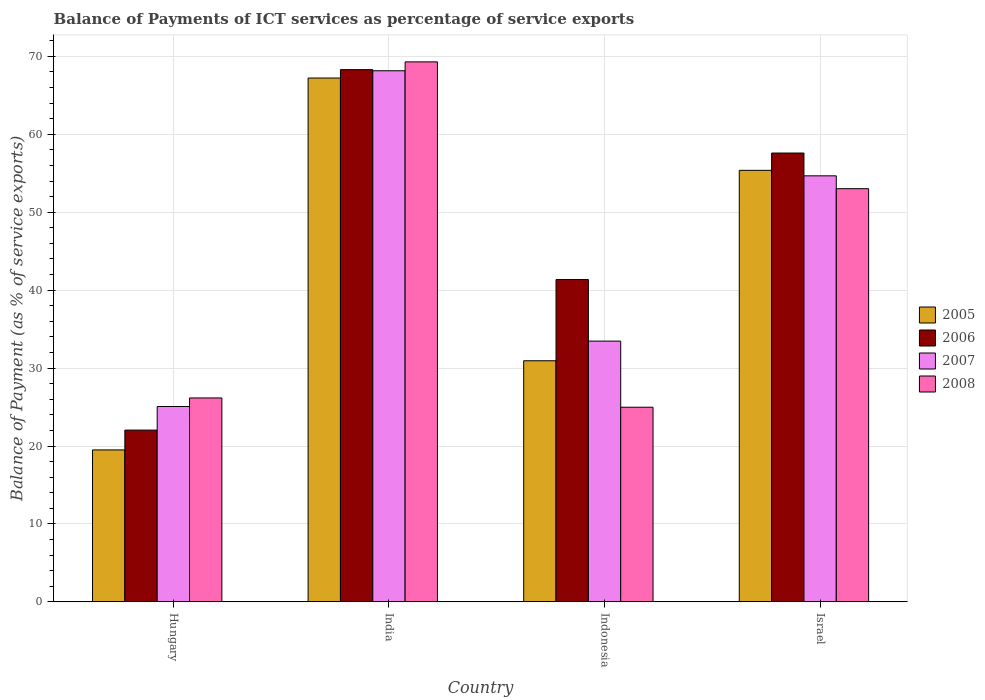How many groups of bars are there?
Ensure brevity in your answer.  4. What is the label of the 2nd group of bars from the left?
Ensure brevity in your answer.  India. In how many cases, is the number of bars for a given country not equal to the number of legend labels?
Give a very brief answer. 0. What is the balance of payments of ICT services in 2008 in Indonesia?
Your answer should be compact. 24.98. Across all countries, what is the maximum balance of payments of ICT services in 2007?
Give a very brief answer. 68.15. Across all countries, what is the minimum balance of payments of ICT services in 2006?
Your answer should be very brief. 22.04. In which country was the balance of payments of ICT services in 2008 maximum?
Your answer should be very brief. India. In which country was the balance of payments of ICT services in 2005 minimum?
Your response must be concise. Hungary. What is the total balance of payments of ICT services in 2008 in the graph?
Offer a terse response. 173.45. What is the difference between the balance of payments of ICT services in 2008 in India and that in Indonesia?
Ensure brevity in your answer.  44.31. What is the difference between the balance of payments of ICT services in 2007 in Israel and the balance of payments of ICT services in 2008 in Hungary?
Offer a terse response. 28.5. What is the average balance of payments of ICT services in 2008 per country?
Make the answer very short. 43.36. What is the difference between the balance of payments of ICT services of/in 2008 and balance of payments of ICT services of/in 2007 in Hungary?
Ensure brevity in your answer.  1.1. In how many countries, is the balance of payments of ICT services in 2008 greater than 62 %?
Give a very brief answer. 1. What is the ratio of the balance of payments of ICT services in 2005 in Hungary to that in Indonesia?
Your response must be concise. 0.63. Is the balance of payments of ICT services in 2005 in India less than that in Israel?
Offer a very short reply. No. What is the difference between the highest and the second highest balance of payments of ICT services in 2005?
Give a very brief answer. 36.28. What is the difference between the highest and the lowest balance of payments of ICT services in 2006?
Offer a terse response. 46.25. Is the sum of the balance of payments of ICT services in 2006 in Indonesia and Israel greater than the maximum balance of payments of ICT services in 2005 across all countries?
Ensure brevity in your answer.  Yes. What does the 2nd bar from the left in India represents?
Keep it short and to the point. 2006. What does the 3rd bar from the right in Israel represents?
Make the answer very short. 2006. How many bars are there?
Offer a very short reply. 16. How many countries are there in the graph?
Keep it short and to the point. 4. Does the graph contain any zero values?
Offer a terse response. No. Does the graph contain grids?
Offer a very short reply. Yes. What is the title of the graph?
Make the answer very short. Balance of Payments of ICT services as percentage of service exports. What is the label or title of the X-axis?
Ensure brevity in your answer.  Country. What is the label or title of the Y-axis?
Ensure brevity in your answer.  Balance of Payment (as % of service exports). What is the Balance of Payment (as % of service exports) in 2005 in Hungary?
Offer a very short reply. 19.5. What is the Balance of Payment (as % of service exports) of 2006 in Hungary?
Your response must be concise. 22.04. What is the Balance of Payment (as % of service exports) of 2007 in Hungary?
Your answer should be compact. 25.07. What is the Balance of Payment (as % of service exports) in 2008 in Hungary?
Ensure brevity in your answer.  26.17. What is the Balance of Payment (as % of service exports) of 2005 in India?
Your answer should be very brief. 67.22. What is the Balance of Payment (as % of service exports) in 2006 in India?
Your answer should be very brief. 68.29. What is the Balance of Payment (as % of service exports) of 2007 in India?
Your answer should be very brief. 68.15. What is the Balance of Payment (as % of service exports) in 2008 in India?
Provide a succinct answer. 69.29. What is the Balance of Payment (as % of service exports) in 2005 in Indonesia?
Provide a succinct answer. 30.94. What is the Balance of Payment (as % of service exports) in 2006 in Indonesia?
Make the answer very short. 41.36. What is the Balance of Payment (as % of service exports) in 2007 in Indonesia?
Provide a short and direct response. 33.46. What is the Balance of Payment (as % of service exports) of 2008 in Indonesia?
Give a very brief answer. 24.98. What is the Balance of Payment (as % of service exports) of 2005 in Israel?
Keep it short and to the point. 55.37. What is the Balance of Payment (as % of service exports) of 2006 in Israel?
Provide a short and direct response. 57.59. What is the Balance of Payment (as % of service exports) in 2007 in Israel?
Keep it short and to the point. 54.67. What is the Balance of Payment (as % of service exports) in 2008 in Israel?
Your answer should be compact. 53.02. Across all countries, what is the maximum Balance of Payment (as % of service exports) of 2005?
Provide a succinct answer. 67.22. Across all countries, what is the maximum Balance of Payment (as % of service exports) in 2006?
Your response must be concise. 68.29. Across all countries, what is the maximum Balance of Payment (as % of service exports) of 2007?
Offer a terse response. 68.15. Across all countries, what is the maximum Balance of Payment (as % of service exports) of 2008?
Provide a short and direct response. 69.29. Across all countries, what is the minimum Balance of Payment (as % of service exports) of 2005?
Offer a terse response. 19.5. Across all countries, what is the minimum Balance of Payment (as % of service exports) of 2006?
Your response must be concise. 22.04. Across all countries, what is the minimum Balance of Payment (as % of service exports) of 2007?
Offer a very short reply. 25.07. Across all countries, what is the minimum Balance of Payment (as % of service exports) of 2008?
Keep it short and to the point. 24.98. What is the total Balance of Payment (as % of service exports) in 2005 in the graph?
Provide a short and direct response. 173.03. What is the total Balance of Payment (as % of service exports) of 2006 in the graph?
Your answer should be very brief. 189.29. What is the total Balance of Payment (as % of service exports) in 2007 in the graph?
Provide a short and direct response. 181.34. What is the total Balance of Payment (as % of service exports) of 2008 in the graph?
Provide a short and direct response. 173.45. What is the difference between the Balance of Payment (as % of service exports) of 2005 in Hungary and that in India?
Your answer should be very brief. -47.72. What is the difference between the Balance of Payment (as % of service exports) in 2006 in Hungary and that in India?
Give a very brief answer. -46.25. What is the difference between the Balance of Payment (as % of service exports) of 2007 in Hungary and that in India?
Your answer should be compact. -43.08. What is the difference between the Balance of Payment (as % of service exports) in 2008 in Hungary and that in India?
Give a very brief answer. -43.12. What is the difference between the Balance of Payment (as % of service exports) of 2005 in Hungary and that in Indonesia?
Ensure brevity in your answer.  -11.44. What is the difference between the Balance of Payment (as % of service exports) in 2006 in Hungary and that in Indonesia?
Make the answer very short. -19.32. What is the difference between the Balance of Payment (as % of service exports) in 2007 in Hungary and that in Indonesia?
Provide a short and direct response. -8.39. What is the difference between the Balance of Payment (as % of service exports) of 2008 in Hungary and that in Indonesia?
Keep it short and to the point. 1.19. What is the difference between the Balance of Payment (as % of service exports) of 2005 in Hungary and that in Israel?
Keep it short and to the point. -35.88. What is the difference between the Balance of Payment (as % of service exports) in 2006 in Hungary and that in Israel?
Ensure brevity in your answer.  -35.55. What is the difference between the Balance of Payment (as % of service exports) of 2007 in Hungary and that in Israel?
Your answer should be compact. -29.6. What is the difference between the Balance of Payment (as % of service exports) in 2008 in Hungary and that in Israel?
Offer a terse response. -26.85. What is the difference between the Balance of Payment (as % of service exports) of 2005 in India and that in Indonesia?
Your answer should be compact. 36.28. What is the difference between the Balance of Payment (as % of service exports) in 2006 in India and that in Indonesia?
Your response must be concise. 26.93. What is the difference between the Balance of Payment (as % of service exports) of 2007 in India and that in Indonesia?
Your answer should be very brief. 34.69. What is the difference between the Balance of Payment (as % of service exports) of 2008 in India and that in Indonesia?
Offer a terse response. 44.31. What is the difference between the Balance of Payment (as % of service exports) in 2005 in India and that in Israel?
Give a very brief answer. 11.85. What is the difference between the Balance of Payment (as % of service exports) of 2006 in India and that in Israel?
Give a very brief answer. 10.7. What is the difference between the Balance of Payment (as % of service exports) of 2007 in India and that in Israel?
Provide a short and direct response. 13.48. What is the difference between the Balance of Payment (as % of service exports) in 2008 in India and that in Israel?
Offer a very short reply. 16.27. What is the difference between the Balance of Payment (as % of service exports) in 2005 in Indonesia and that in Israel?
Keep it short and to the point. -24.44. What is the difference between the Balance of Payment (as % of service exports) of 2006 in Indonesia and that in Israel?
Offer a terse response. -16.23. What is the difference between the Balance of Payment (as % of service exports) in 2007 in Indonesia and that in Israel?
Offer a very short reply. -21.21. What is the difference between the Balance of Payment (as % of service exports) of 2008 in Indonesia and that in Israel?
Provide a short and direct response. -28.04. What is the difference between the Balance of Payment (as % of service exports) in 2005 in Hungary and the Balance of Payment (as % of service exports) in 2006 in India?
Offer a terse response. -48.8. What is the difference between the Balance of Payment (as % of service exports) of 2005 in Hungary and the Balance of Payment (as % of service exports) of 2007 in India?
Offer a terse response. -48.65. What is the difference between the Balance of Payment (as % of service exports) in 2005 in Hungary and the Balance of Payment (as % of service exports) in 2008 in India?
Provide a short and direct response. -49.79. What is the difference between the Balance of Payment (as % of service exports) of 2006 in Hungary and the Balance of Payment (as % of service exports) of 2007 in India?
Offer a very short reply. -46.11. What is the difference between the Balance of Payment (as % of service exports) of 2006 in Hungary and the Balance of Payment (as % of service exports) of 2008 in India?
Ensure brevity in your answer.  -47.25. What is the difference between the Balance of Payment (as % of service exports) in 2007 in Hungary and the Balance of Payment (as % of service exports) in 2008 in India?
Give a very brief answer. -44.22. What is the difference between the Balance of Payment (as % of service exports) of 2005 in Hungary and the Balance of Payment (as % of service exports) of 2006 in Indonesia?
Your answer should be compact. -21.87. What is the difference between the Balance of Payment (as % of service exports) of 2005 in Hungary and the Balance of Payment (as % of service exports) of 2007 in Indonesia?
Your answer should be compact. -13.96. What is the difference between the Balance of Payment (as % of service exports) of 2005 in Hungary and the Balance of Payment (as % of service exports) of 2008 in Indonesia?
Give a very brief answer. -5.48. What is the difference between the Balance of Payment (as % of service exports) in 2006 in Hungary and the Balance of Payment (as % of service exports) in 2007 in Indonesia?
Provide a short and direct response. -11.42. What is the difference between the Balance of Payment (as % of service exports) of 2006 in Hungary and the Balance of Payment (as % of service exports) of 2008 in Indonesia?
Offer a very short reply. -2.94. What is the difference between the Balance of Payment (as % of service exports) of 2007 in Hungary and the Balance of Payment (as % of service exports) of 2008 in Indonesia?
Provide a succinct answer. 0.09. What is the difference between the Balance of Payment (as % of service exports) in 2005 in Hungary and the Balance of Payment (as % of service exports) in 2006 in Israel?
Provide a short and direct response. -38.1. What is the difference between the Balance of Payment (as % of service exports) in 2005 in Hungary and the Balance of Payment (as % of service exports) in 2007 in Israel?
Keep it short and to the point. -35.17. What is the difference between the Balance of Payment (as % of service exports) in 2005 in Hungary and the Balance of Payment (as % of service exports) in 2008 in Israel?
Make the answer very short. -33.52. What is the difference between the Balance of Payment (as % of service exports) of 2006 in Hungary and the Balance of Payment (as % of service exports) of 2007 in Israel?
Provide a short and direct response. -32.63. What is the difference between the Balance of Payment (as % of service exports) of 2006 in Hungary and the Balance of Payment (as % of service exports) of 2008 in Israel?
Offer a very short reply. -30.98. What is the difference between the Balance of Payment (as % of service exports) in 2007 in Hungary and the Balance of Payment (as % of service exports) in 2008 in Israel?
Ensure brevity in your answer.  -27.95. What is the difference between the Balance of Payment (as % of service exports) of 2005 in India and the Balance of Payment (as % of service exports) of 2006 in Indonesia?
Give a very brief answer. 25.86. What is the difference between the Balance of Payment (as % of service exports) of 2005 in India and the Balance of Payment (as % of service exports) of 2007 in Indonesia?
Offer a very short reply. 33.76. What is the difference between the Balance of Payment (as % of service exports) in 2005 in India and the Balance of Payment (as % of service exports) in 2008 in Indonesia?
Your answer should be very brief. 42.24. What is the difference between the Balance of Payment (as % of service exports) of 2006 in India and the Balance of Payment (as % of service exports) of 2007 in Indonesia?
Ensure brevity in your answer.  34.84. What is the difference between the Balance of Payment (as % of service exports) in 2006 in India and the Balance of Payment (as % of service exports) in 2008 in Indonesia?
Provide a succinct answer. 43.32. What is the difference between the Balance of Payment (as % of service exports) in 2007 in India and the Balance of Payment (as % of service exports) in 2008 in Indonesia?
Your answer should be very brief. 43.17. What is the difference between the Balance of Payment (as % of service exports) of 2005 in India and the Balance of Payment (as % of service exports) of 2006 in Israel?
Ensure brevity in your answer.  9.63. What is the difference between the Balance of Payment (as % of service exports) in 2005 in India and the Balance of Payment (as % of service exports) in 2007 in Israel?
Offer a very short reply. 12.55. What is the difference between the Balance of Payment (as % of service exports) in 2005 in India and the Balance of Payment (as % of service exports) in 2008 in Israel?
Offer a terse response. 14.2. What is the difference between the Balance of Payment (as % of service exports) in 2006 in India and the Balance of Payment (as % of service exports) in 2007 in Israel?
Provide a short and direct response. 13.63. What is the difference between the Balance of Payment (as % of service exports) in 2006 in India and the Balance of Payment (as % of service exports) in 2008 in Israel?
Keep it short and to the point. 15.28. What is the difference between the Balance of Payment (as % of service exports) of 2007 in India and the Balance of Payment (as % of service exports) of 2008 in Israel?
Make the answer very short. 15.13. What is the difference between the Balance of Payment (as % of service exports) in 2005 in Indonesia and the Balance of Payment (as % of service exports) in 2006 in Israel?
Ensure brevity in your answer.  -26.65. What is the difference between the Balance of Payment (as % of service exports) in 2005 in Indonesia and the Balance of Payment (as % of service exports) in 2007 in Israel?
Give a very brief answer. -23.73. What is the difference between the Balance of Payment (as % of service exports) in 2005 in Indonesia and the Balance of Payment (as % of service exports) in 2008 in Israel?
Give a very brief answer. -22.08. What is the difference between the Balance of Payment (as % of service exports) in 2006 in Indonesia and the Balance of Payment (as % of service exports) in 2007 in Israel?
Ensure brevity in your answer.  -13.3. What is the difference between the Balance of Payment (as % of service exports) in 2006 in Indonesia and the Balance of Payment (as % of service exports) in 2008 in Israel?
Offer a terse response. -11.66. What is the difference between the Balance of Payment (as % of service exports) of 2007 in Indonesia and the Balance of Payment (as % of service exports) of 2008 in Israel?
Your response must be concise. -19.56. What is the average Balance of Payment (as % of service exports) of 2005 per country?
Your answer should be very brief. 43.26. What is the average Balance of Payment (as % of service exports) in 2006 per country?
Your response must be concise. 47.32. What is the average Balance of Payment (as % of service exports) of 2007 per country?
Your answer should be compact. 45.34. What is the average Balance of Payment (as % of service exports) of 2008 per country?
Give a very brief answer. 43.36. What is the difference between the Balance of Payment (as % of service exports) of 2005 and Balance of Payment (as % of service exports) of 2006 in Hungary?
Ensure brevity in your answer.  -2.55. What is the difference between the Balance of Payment (as % of service exports) in 2005 and Balance of Payment (as % of service exports) in 2007 in Hungary?
Your answer should be compact. -5.57. What is the difference between the Balance of Payment (as % of service exports) in 2005 and Balance of Payment (as % of service exports) in 2008 in Hungary?
Provide a succinct answer. -6.67. What is the difference between the Balance of Payment (as % of service exports) of 2006 and Balance of Payment (as % of service exports) of 2007 in Hungary?
Your answer should be compact. -3.03. What is the difference between the Balance of Payment (as % of service exports) in 2006 and Balance of Payment (as % of service exports) in 2008 in Hungary?
Make the answer very short. -4.13. What is the difference between the Balance of Payment (as % of service exports) in 2007 and Balance of Payment (as % of service exports) in 2008 in Hungary?
Give a very brief answer. -1.1. What is the difference between the Balance of Payment (as % of service exports) in 2005 and Balance of Payment (as % of service exports) in 2006 in India?
Offer a very short reply. -1.08. What is the difference between the Balance of Payment (as % of service exports) of 2005 and Balance of Payment (as % of service exports) of 2007 in India?
Your answer should be compact. -0.93. What is the difference between the Balance of Payment (as % of service exports) in 2005 and Balance of Payment (as % of service exports) in 2008 in India?
Your response must be concise. -2.07. What is the difference between the Balance of Payment (as % of service exports) in 2006 and Balance of Payment (as % of service exports) in 2007 in India?
Keep it short and to the point. 0.15. What is the difference between the Balance of Payment (as % of service exports) of 2006 and Balance of Payment (as % of service exports) of 2008 in India?
Make the answer very short. -0.99. What is the difference between the Balance of Payment (as % of service exports) in 2007 and Balance of Payment (as % of service exports) in 2008 in India?
Your answer should be compact. -1.14. What is the difference between the Balance of Payment (as % of service exports) of 2005 and Balance of Payment (as % of service exports) of 2006 in Indonesia?
Your answer should be very brief. -10.42. What is the difference between the Balance of Payment (as % of service exports) in 2005 and Balance of Payment (as % of service exports) in 2007 in Indonesia?
Your answer should be compact. -2.52. What is the difference between the Balance of Payment (as % of service exports) in 2005 and Balance of Payment (as % of service exports) in 2008 in Indonesia?
Ensure brevity in your answer.  5.96. What is the difference between the Balance of Payment (as % of service exports) of 2006 and Balance of Payment (as % of service exports) of 2007 in Indonesia?
Give a very brief answer. 7.9. What is the difference between the Balance of Payment (as % of service exports) of 2006 and Balance of Payment (as % of service exports) of 2008 in Indonesia?
Your answer should be compact. 16.39. What is the difference between the Balance of Payment (as % of service exports) of 2007 and Balance of Payment (as % of service exports) of 2008 in Indonesia?
Give a very brief answer. 8.48. What is the difference between the Balance of Payment (as % of service exports) of 2005 and Balance of Payment (as % of service exports) of 2006 in Israel?
Ensure brevity in your answer.  -2.22. What is the difference between the Balance of Payment (as % of service exports) in 2005 and Balance of Payment (as % of service exports) in 2007 in Israel?
Your response must be concise. 0.71. What is the difference between the Balance of Payment (as % of service exports) of 2005 and Balance of Payment (as % of service exports) of 2008 in Israel?
Give a very brief answer. 2.36. What is the difference between the Balance of Payment (as % of service exports) in 2006 and Balance of Payment (as % of service exports) in 2007 in Israel?
Offer a terse response. 2.93. What is the difference between the Balance of Payment (as % of service exports) in 2006 and Balance of Payment (as % of service exports) in 2008 in Israel?
Ensure brevity in your answer.  4.57. What is the difference between the Balance of Payment (as % of service exports) of 2007 and Balance of Payment (as % of service exports) of 2008 in Israel?
Provide a short and direct response. 1.65. What is the ratio of the Balance of Payment (as % of service exports) of 2005 in Hungary to that in India?
Your answer should be very brief. 0.29. What is the ratio of the Balance of Payment (as % of service exports) of 2006 in Hungary to that in India?
Offer a very short reply. 0.32. What is the ratio of the Balance of Payment (as % of service exports) in 2007 in Hungary to that in India?
Your answer should be compact. 0.37. What is the ratio of the Balance of Payment (as % of service exports) of 2008 in Hungary to that in India?
Provide a succinct answer. 0.38. What is the ratio of the Balance of Payment (as % of service exports) in 2005 in Hungary to that in Indonesia?
Your answer should be very brief. 0.63. What is the ratio of the Balance of Payment (as % of service exports) in 2006 in Hungary to that in Indonesia?
Provide a short and direct response. 0.53. What is the ratio of the Balance of Payment (as % of service exports) of 2007 in Hungary to that in Indonesia?
Offer a terse response. 0.75. What is the ratio of the Balance of Payment (as % of service exports) of 2008 in Hungary to that in Indonesia?
Provide a succinct answer. 1.05. What is the ratio of the Balance of Payment (as % of service exports) in 2005 in Hungary to that in Israel?
Offer a terse response. 0.35. What is the ratio of the Balance of Payment (as % of service exports) in 2006 in Hungary to that in Israel?
Your answer should be compact. 0.38. What is the ratio of the Balance of Payment (as % of service exports) of 2007 in Hungary to that in Israel?
Offer a terse response. 0.46. What is the ratio of the Balance of Payment (as % of service exports) in 2008 in Hungary to that in Israel?
Keep it short and to the point. 0.49. What is the ratio of the Balance of Payment (as % of service exports) of 2005 in India to that in Indonesia?
Provide a succinct answer. 2.17. What is the ratio of the Balance of Payment (as % of service exports) of 2006 in India to that in Indonesia?
Your answer should be compact. 1.65. What is the ratio of the Balance of Payment (as % of service exports) in 2007 in India to that in Indonesia?
Provide a succinct answer. 2.04. What is the ratio of the Balance of Payment (as % of service exports) in 2008 in India to that in Indonesia?
Give a very brief answer. 2.77. What is the ratio of the Balance of Payment (as % of service exports) of 2005 in India to that in Israel?
Offer a very short reply. 1.21. What is the ratio of the Balance of Payment (as % of service exports) of 2006 in India to that in Israel?
Your answer should be compact. 1.19. What is the ratio of the Balance of Payment (as % of service exports) in 2007 in India to that in Israel?
Provide a succinct answer. 1.25. What is the ratio of the Balance of Payment (as % of service exports) in 2008 in India to that in Israel?
Ensure brevity in your answer.  1.31. What is the ratio of the Balance of Payment (as % of service exports) in 2005 in Indonesia to that in Israel?
Give a very brief answer. 0.56. What is the ratio of the Balance of Payment (as % of service exports) in 2006 in Indonesia to that in Israel?
Offer a very short reply. 0.72. What is the ratio of the Balance of Payment (as % of service exports) of 2007 in Indonesia to that in Israel?
Your response must be concise. 0.61. What is the ratio of the Balance of Payment (as % of service exports) of 2008 in Indonesia to that in Israel?
Give a very brief answer. 0.47. What is the difference between the highest and the second highest Balance of Payment (as % of service exports) in 2005?
Your answer should be very brief. 11.85. What is the difference between the highest and the second highest Balance of Payment (as % of service exports) of 2006?
Your response must be concise. 10.7. What is the difference between the highest and the second highest Balance of Payment (as % of service exports) in 2007?
Make the answer very short. 13.48. What is the difference between the highest and the second highest Balance of Payment (as % of service exports) of 2008?
Your answer should be very brief. 16.27. What is the difference between the highest and the lowest Balance of Payment (as % of service exports) of 2005?
Make the answer very short. 47.72. What is the difference between the highest and the lowest Balance of Payment (as % of service exports) of 2006?
Provide a short and direct response. 46.25. What is the difference between the highest and the lowest Balance of Payment (as % of service exports) in 2007?
Keep it short and to the point. 43.08. What is the difference between the highest and the lowest Balance of Payment (as % of service exports) of 2008?
Make the answer very short. 44.31. 